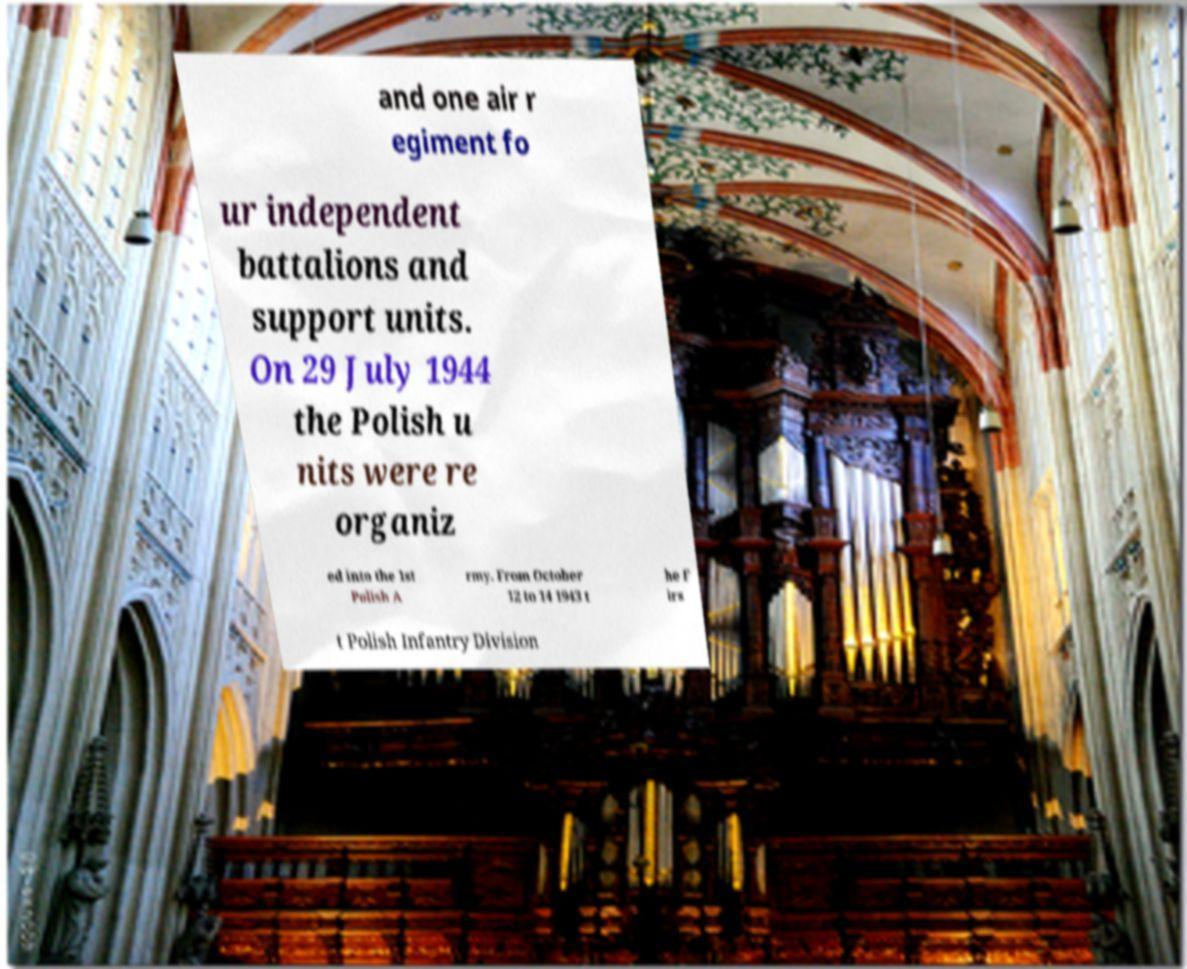Please read and relay the text visible in this image. What does it say? and one air r egiment fo ur independent battalions and support units. On 29 July 1944 the Polish u nits were re organiz ed into the 1st Polish A rmy. From October 12 to 14 1943 t he F irs t Polish Infantry Division 